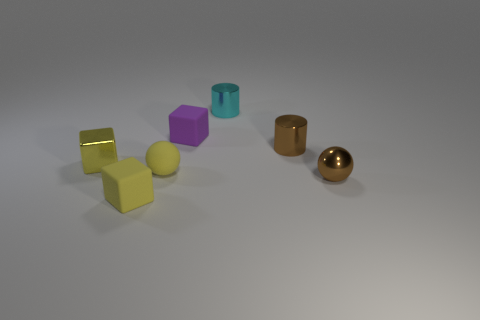Is the color of the rubber sphere the same as the matte object that is in front of the yellow matte ball?
Offer a very short reply. Yes. Is the number of red metal cubes less than the number of yellow balls?
Provide a short and direct response. Yes. Is the color of the cube in front of the tiny metal sphere the same as the small metal cube?
Ensure brevity in your answer.  Yes. What number of shiny objects are the same size as the brown metal ball?
Offer a terse response. 3. Is there a tiny rubber ball of the same color as the tiny metal block?
Give a very brief answer. Yes. Does the tiny purple thing have the same material as the small cyan cylinder?
Ensure brevity in your answer.  No. What number of other cyan things have the same shape as the cyan object?
Your answer should be very brief. 0. There is a small yellow object that is made of the same material as the small cyan cylinder; what shape is it?
Your answer should be compact. Cube. There is a small matte block that is to the left of the cube that is on the right side of the small yellow matte block; what color is it?
Provide a succinct answer. Yellow. Is the color of the metallic cube the same as the small shiny ball?
Provide a short and direct response. No. 